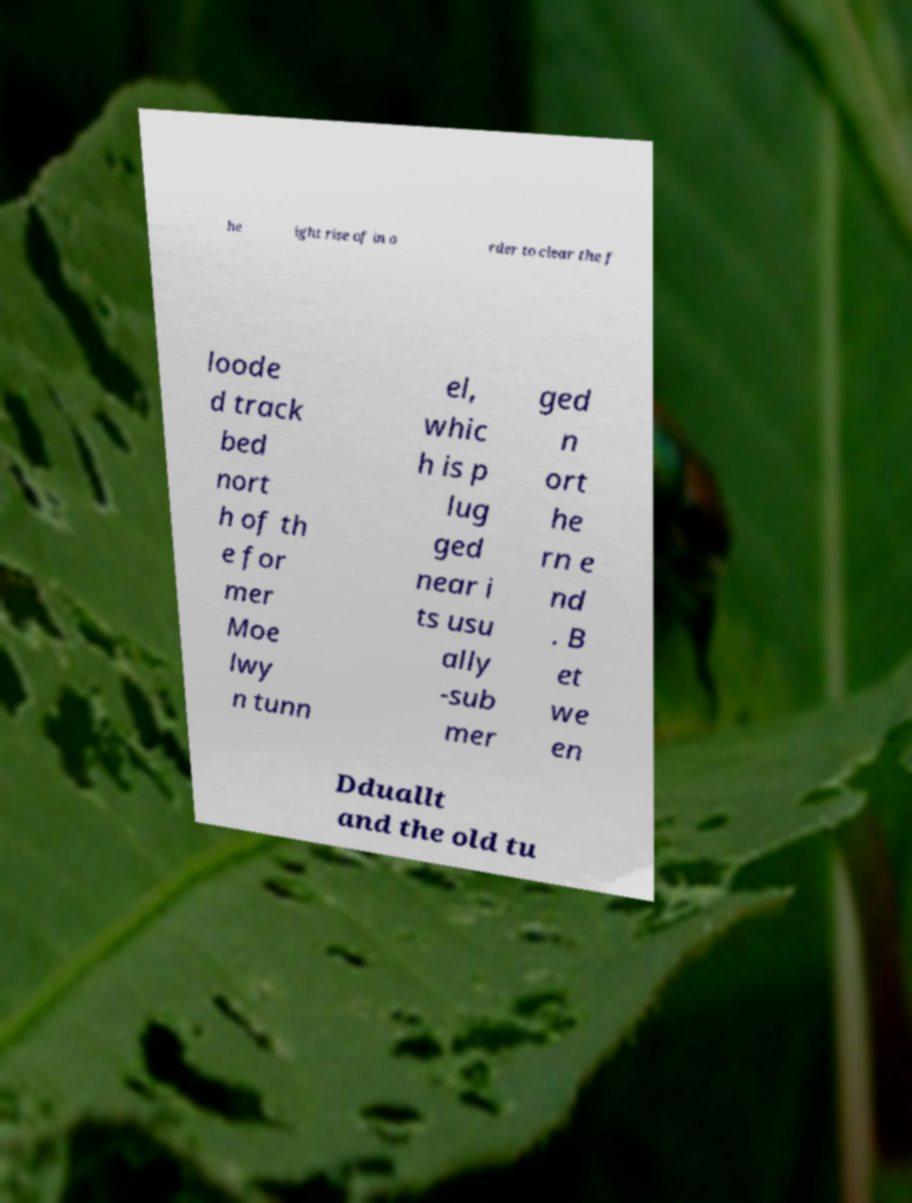Can you accurately transcribe the text from the provided image for me? he ight rise of in o rder to clear the f loode d track bed nort h of th e for mer Moe lwy n tunn el, whic h is p lug ged near i ts usu ally -sub mer ged n ort he rn e nd . B et we en Dduallt and the old tu 